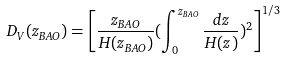<formula> <loc_0><loc_0><loc_500><loc_500>D _ { V } ( z _ { B A O } ) = \left [ \frac { z _ { B A O } } { H ( z _ { B A O } ) } ( \int _ { 0 } ^ { z _ { B A O } } \frac { d z } { H ( z ) } ) ^ { 2 } \right ] ^ { 1 / 3 }</formula> 